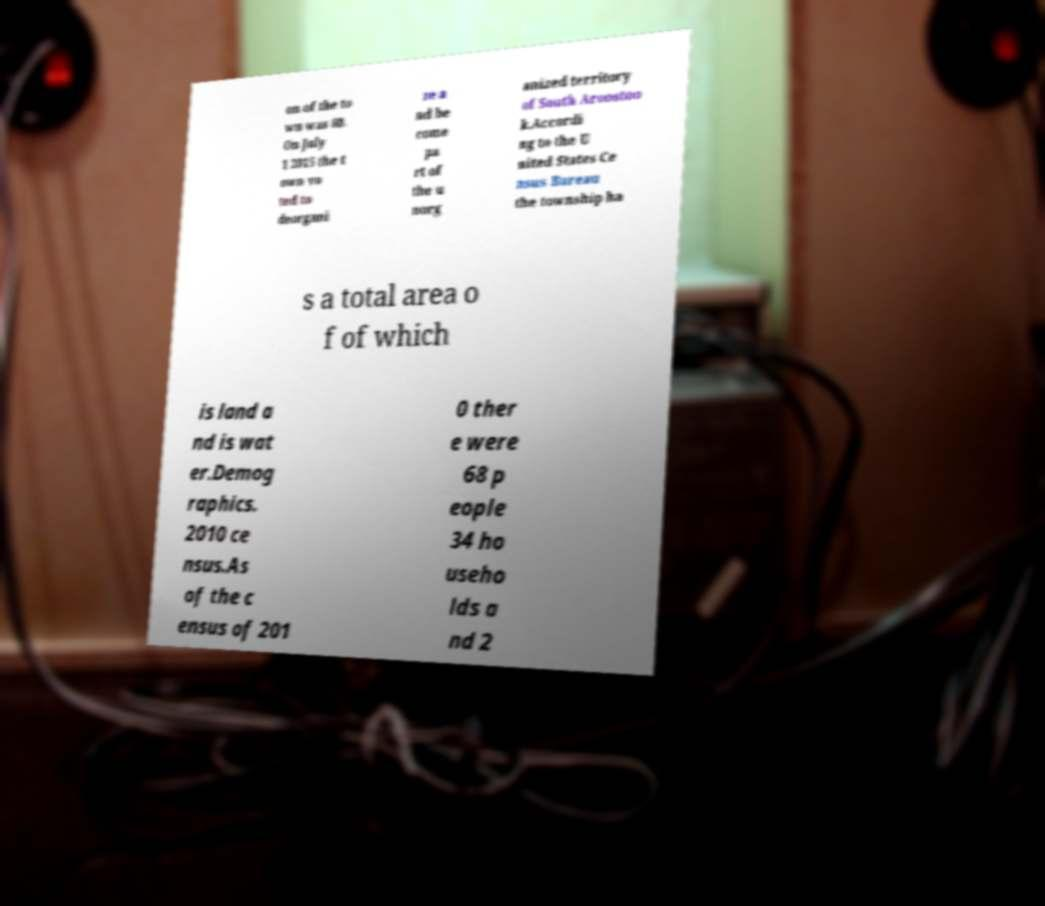Please identify and transcribe the text found in this image. on of the to wn was 60. On July 1 2015 the t own vo ted to deorgani ze a nd be come pa rt of the u norg anized territory of South Aroostoo k.Accordi ng to the U nited States Ce nsus Bureau the township ha s a total area o f of which is land a nd is wat er.Demog raphics. 2010 ce nsus.As of the c ensus of 201 0 ther e were 68 p eople 34 ho useho lds a nd 2 